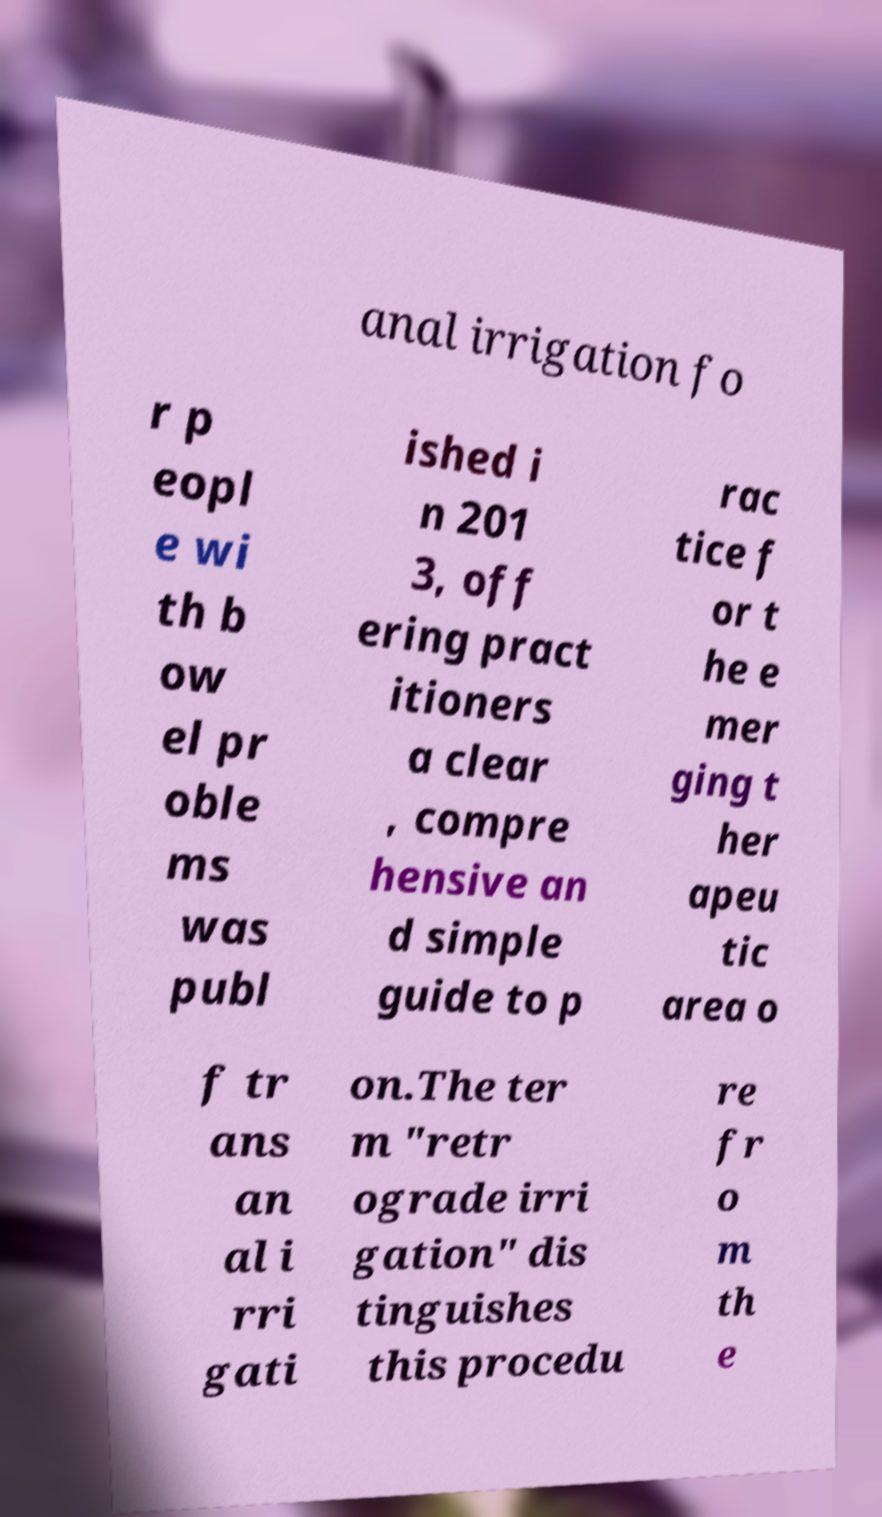Could you extract and type out the text from this image? anal irrigation fo r p eopl e wi th b ow el pr oble ms was publ ished i n 201 3, off ering pract itioners a clear , compre hensive an d simple guide to p rac tice f or t he e mer ging t her apeu tic area o f tr ans an al i rri gati on.The ter m "retr ograde irri gation" dis tinguishes this procedu re fr o m th e 